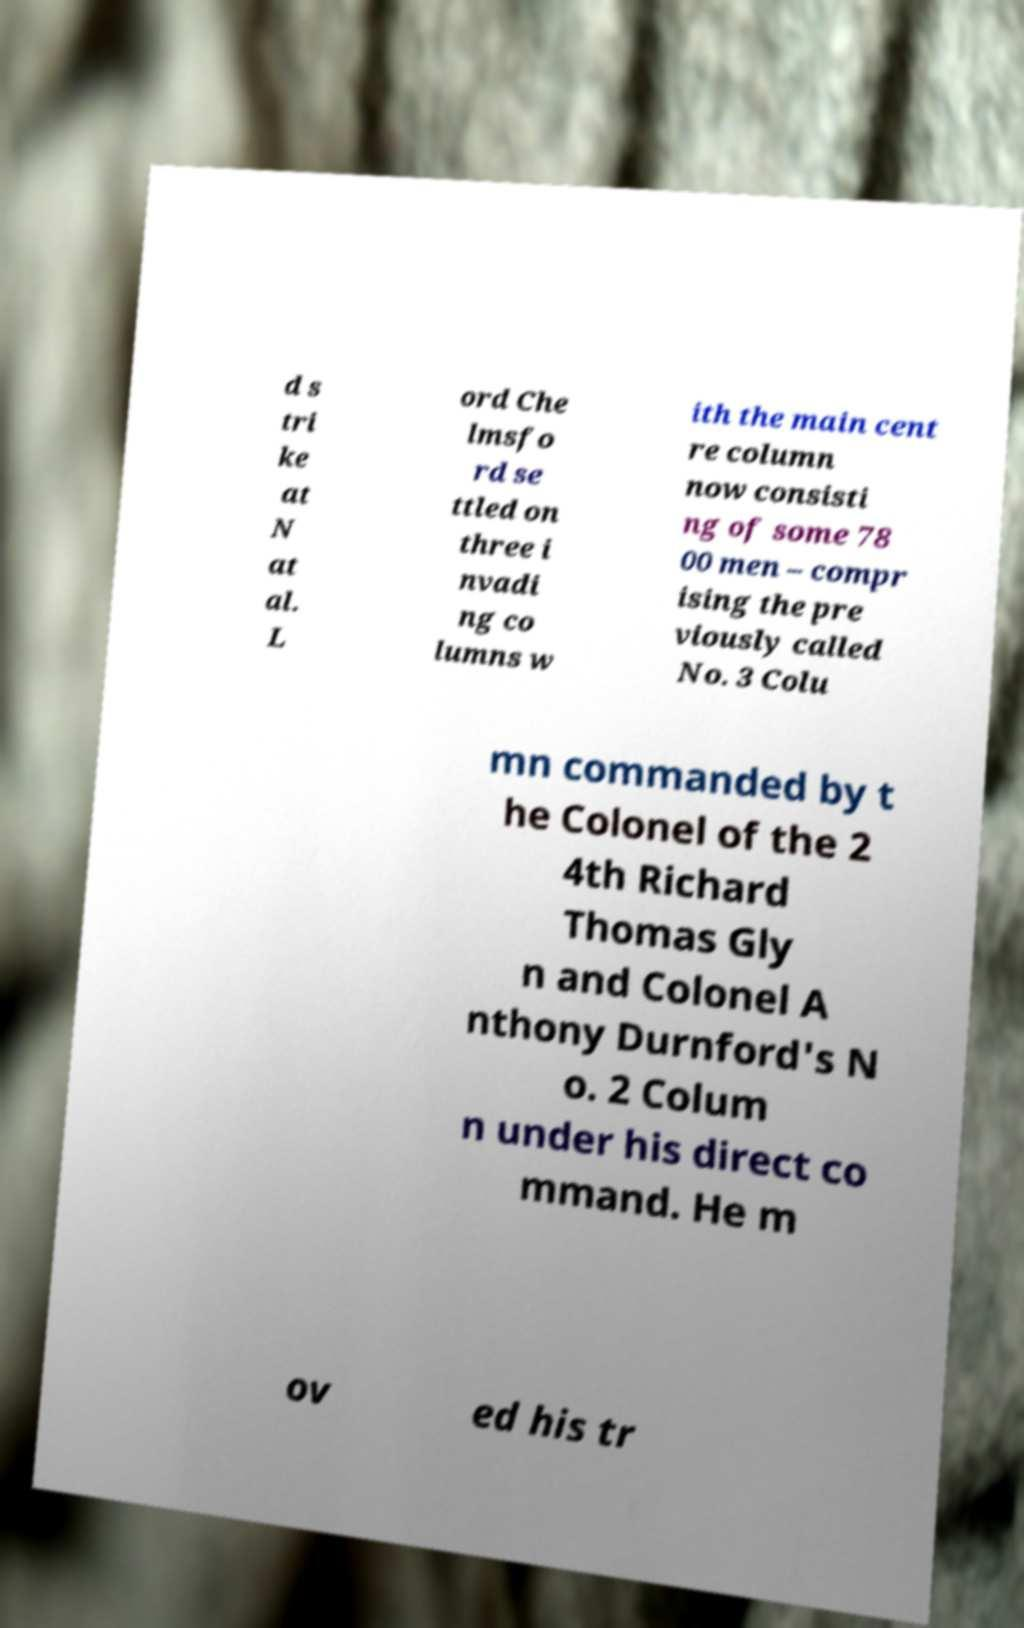Please identify and transcribe the text found in this image. d s tri ke at N at al. L ord Che lmsfo rd se ttled on three i nvadi ng co lumns w ith the main cent re column now consisti ng of some 78 00 men – compr ising the pre viously called No. 3 Colu mn commanded by t he Colonel of the 2 4th Richard Thomas Gly n and Colonel A nthony Durnford's N o. 2 Colum n under his direct co mmand. He m ov ed his tr 